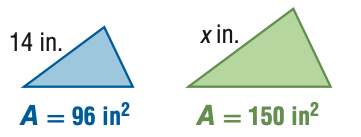Answer the mathemtical geometry problem and directly provide the correct option letter.
Question: For the pair of similar figures, use the given areas to find the scale factor of the blue to the green figure.
Choices: A: \frac { 16 } { 25 } B: \frac { 4 } { 5 } C: \frac { 5 } { 4 } D: \frac { 25 } { 16 } B 